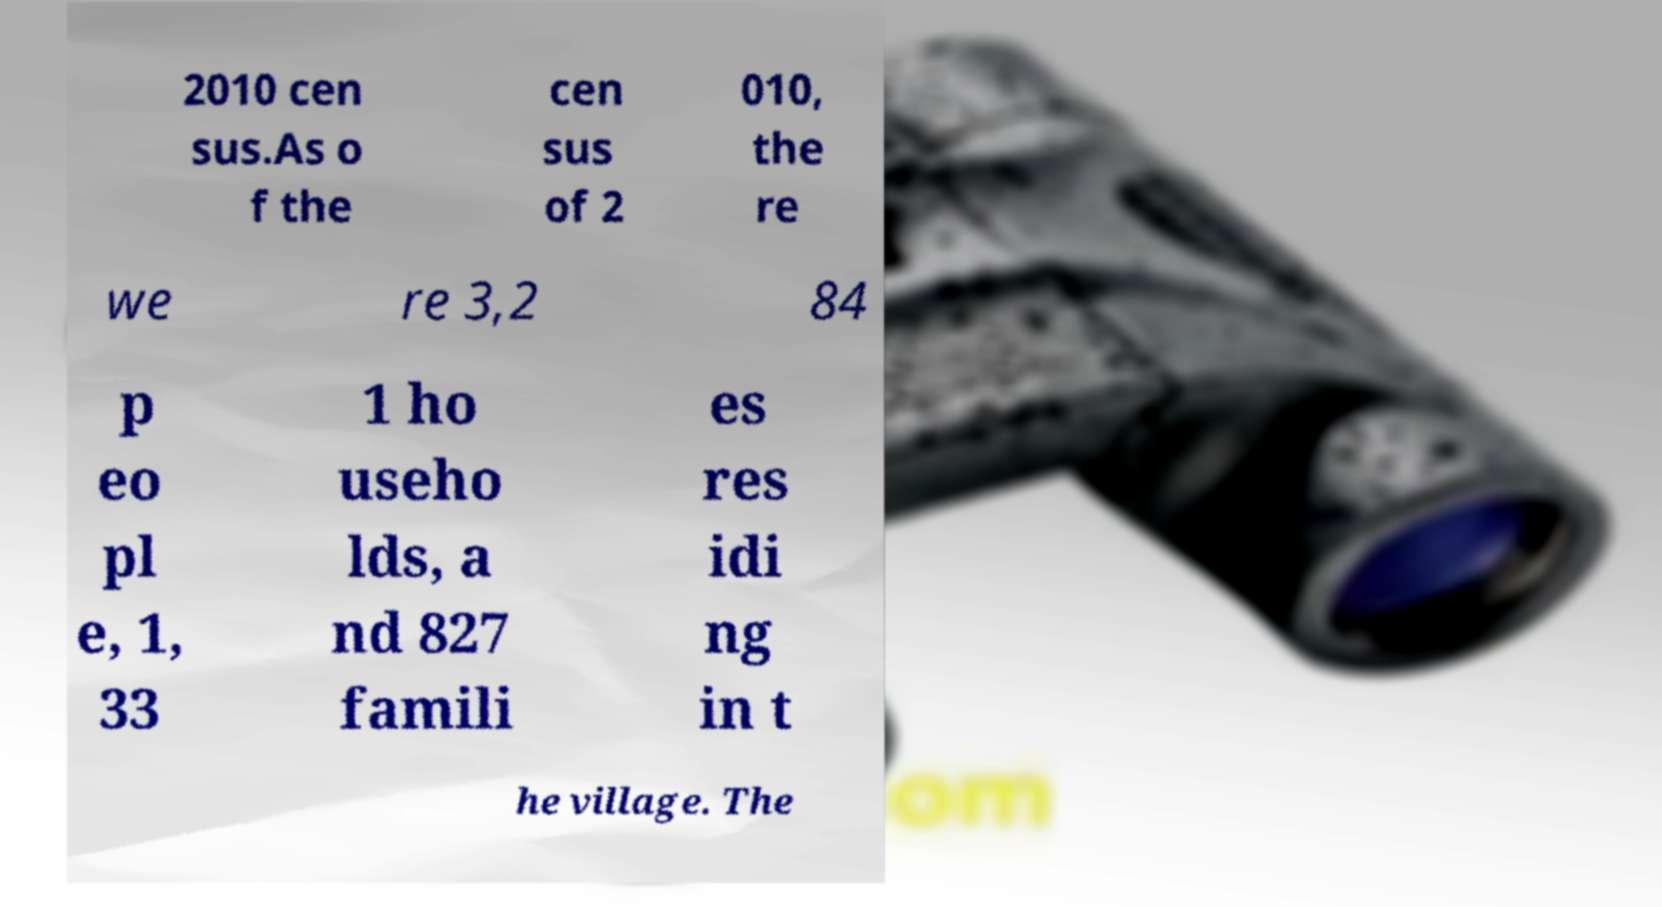Please identify and transcribe the text found in this image. 2010 cen sus.As o f the cen sus of 2 010, the re we re 3,2 84 p eo pl e, 1, 33 1 ho useho lds, a nd 827 famili es res idi ng in t he village. The 